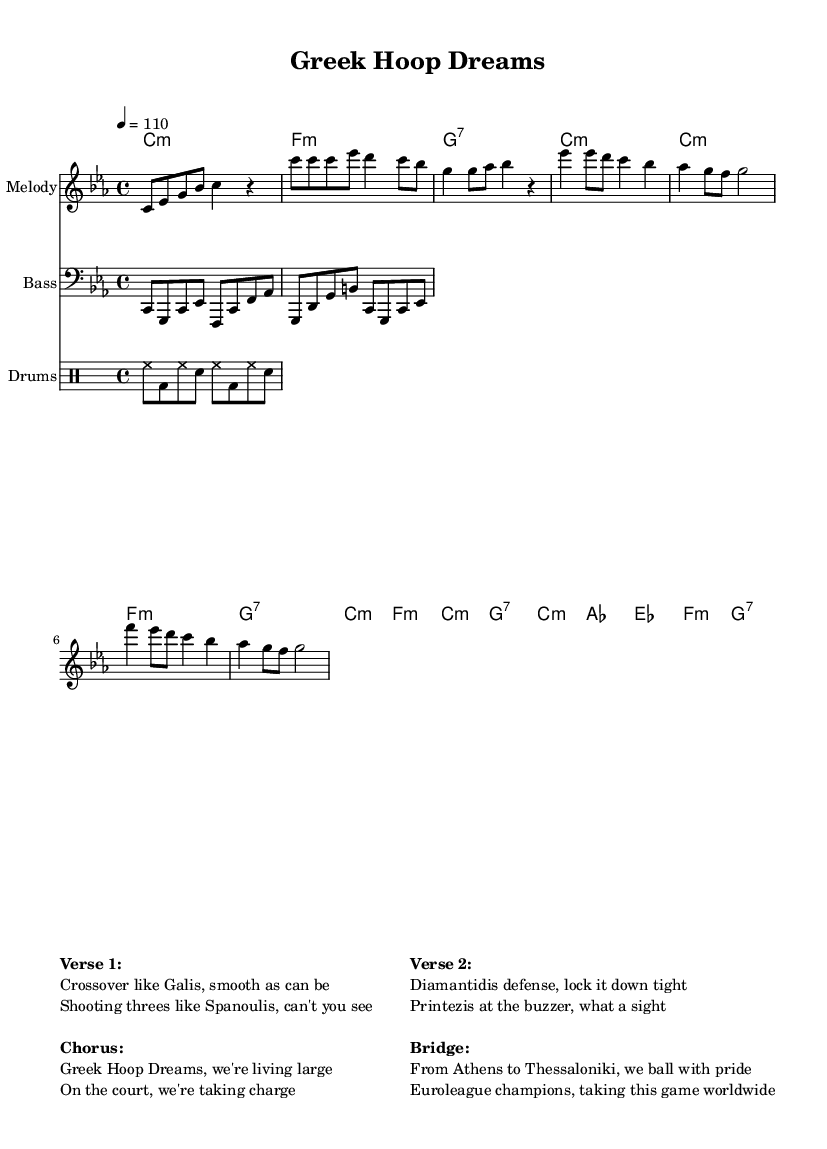What is the key signature of this music? The key signature is C minor, which has three flats: B, E, and A. You can identify this by looking at the key signature indicators at the beginning of the staff, which indicate the specific notes that are altered in this key.
Answer: C minor What is the time signature of this music? The time signature is 4/4, which means there are four beats in each measure and the quarter note receives one beat. This is usually placed at the start of the music and can also be inferred from the rhythmic structure of the piece.
Answer: 4/4 What is the tempo of this music? The tempo marking is 4 = 110, indicating that a quarter note (the 4) is equal to 110 beats per minute (the 110). This means the music should be played at a moderately fast pace. The tempo is specified at the beginning of the score.
Answer: 110 How many sections are there in the music? The music contains four main sections: Intro, Verse, Chorus, and Bridge. This is determined by the distinct labeling and structure of the melody and harmonies, which give a clear separation of these sections.
Answer: Four What is the chorus lyric referencing? The chorus lyrics reference Greek basketball culture, specifically "Greek Hoop Dreams" reflects the aspirations and ambitions of Greek players and fans in basketball. This can be seen in the thematic content mentioned in the chorus, tying it directly to Greek basketball narratives.
Answer: Greek Hoop Dreams Which Greek player is mentioned in the bridge? The bridge references Euroleague champions, symbolizing a collective recognition of Greek players in basketball. While no specific name is mentioned in the bridge, it captures the pride of Greek basketball culture. Since it generalizes several well-known players, it alludes to the many athletes who have contributed to this success.
Answer: Euroleague champions What is the structure of the lyrics in this song? The lyrics follow a verse-chorus-verse bridge format, common in rhythm and blues music. This structure helps create a cohesive narrative while also allowing for a catchy hook in the chorus, which reinforces the theme. This can be identified by the repeated phrases and alignment of lyrics to their respective sections in the melody.
Answer: Verse-chorus-verse-bridge 